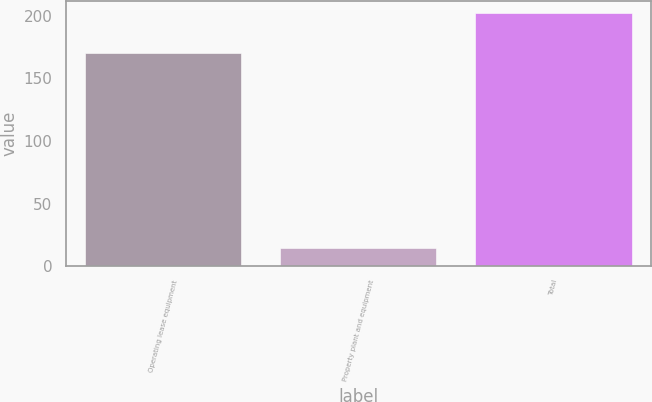<chart> <loc_0><loc_0><loc_500><loc_500><bar_chart><fcel>Operating lease equipment<fcel>Property plant and equipment<fcel>Total<nl><fcel>170<fcel>15<fcel>202<nl></chart> 